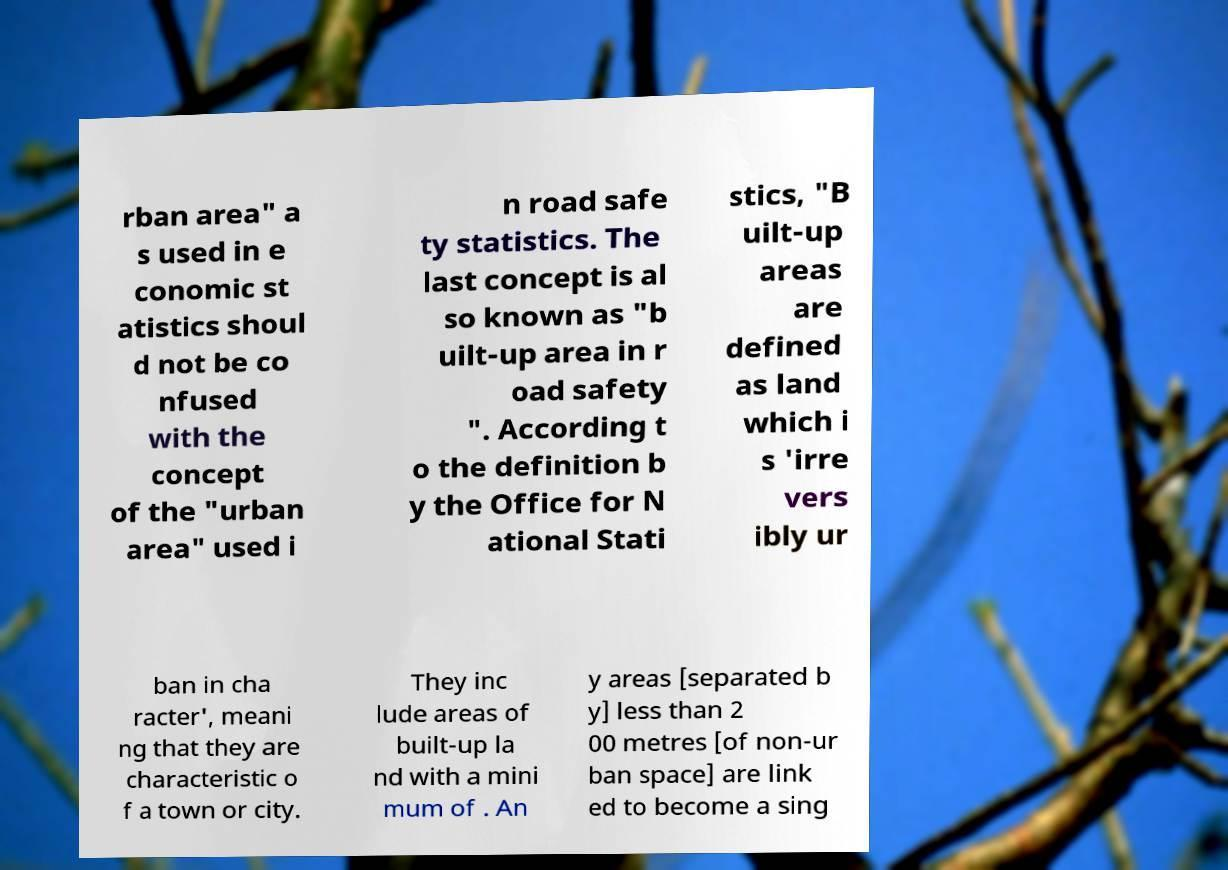Please read and relay the text visible in this image. What does it say? rban area" a s used in e conomic st atistics shoul d not be co nfused with the concept of the "urban area" used i n road safe ty statistics. The last concept is al so known as "b uilt-up area in r oad safety ". According t o the definition b y the Office for N ational Stati stics, "B uilt-up areas are defined as land which i s 'irre vers ibly ur ban in cha racter', meani ng that they are characteristic o f a town or city. They inc lude areas of built-up la nd with a mini mum of . An y areas [separated b y] less than 2 00 metres [of non-ur ban space] are link ed to become a sing 